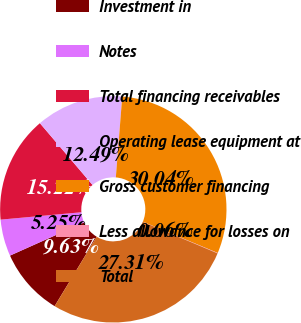Convert chart. <chart><loc_0><loc_0><loc_500><loc_500><pie_chart><fcel>Investment in<fcel>Notes<fcel>Total financing receivables<fcel>Operating lease equipment at<fcel>Gross customer financing<fcel>Less allowance for losses on<fcel>Total<nl><fcel>9.63%<fcel>5.25%<fcel>15.22%<fcel>12.49%<fcel>30.04%<fcel>0.06%<fcel>27.31%<nl></chart> 